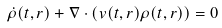Convert formula to latex. <formula><loc_0><loc_0><loc_500><loc_500>\dot { \rho } ( t , { r } ) + { \nabla } \cdot \left ( { v } ( t , { r } ) \rho ( t , { r } ) \right ) = 0</formula> 